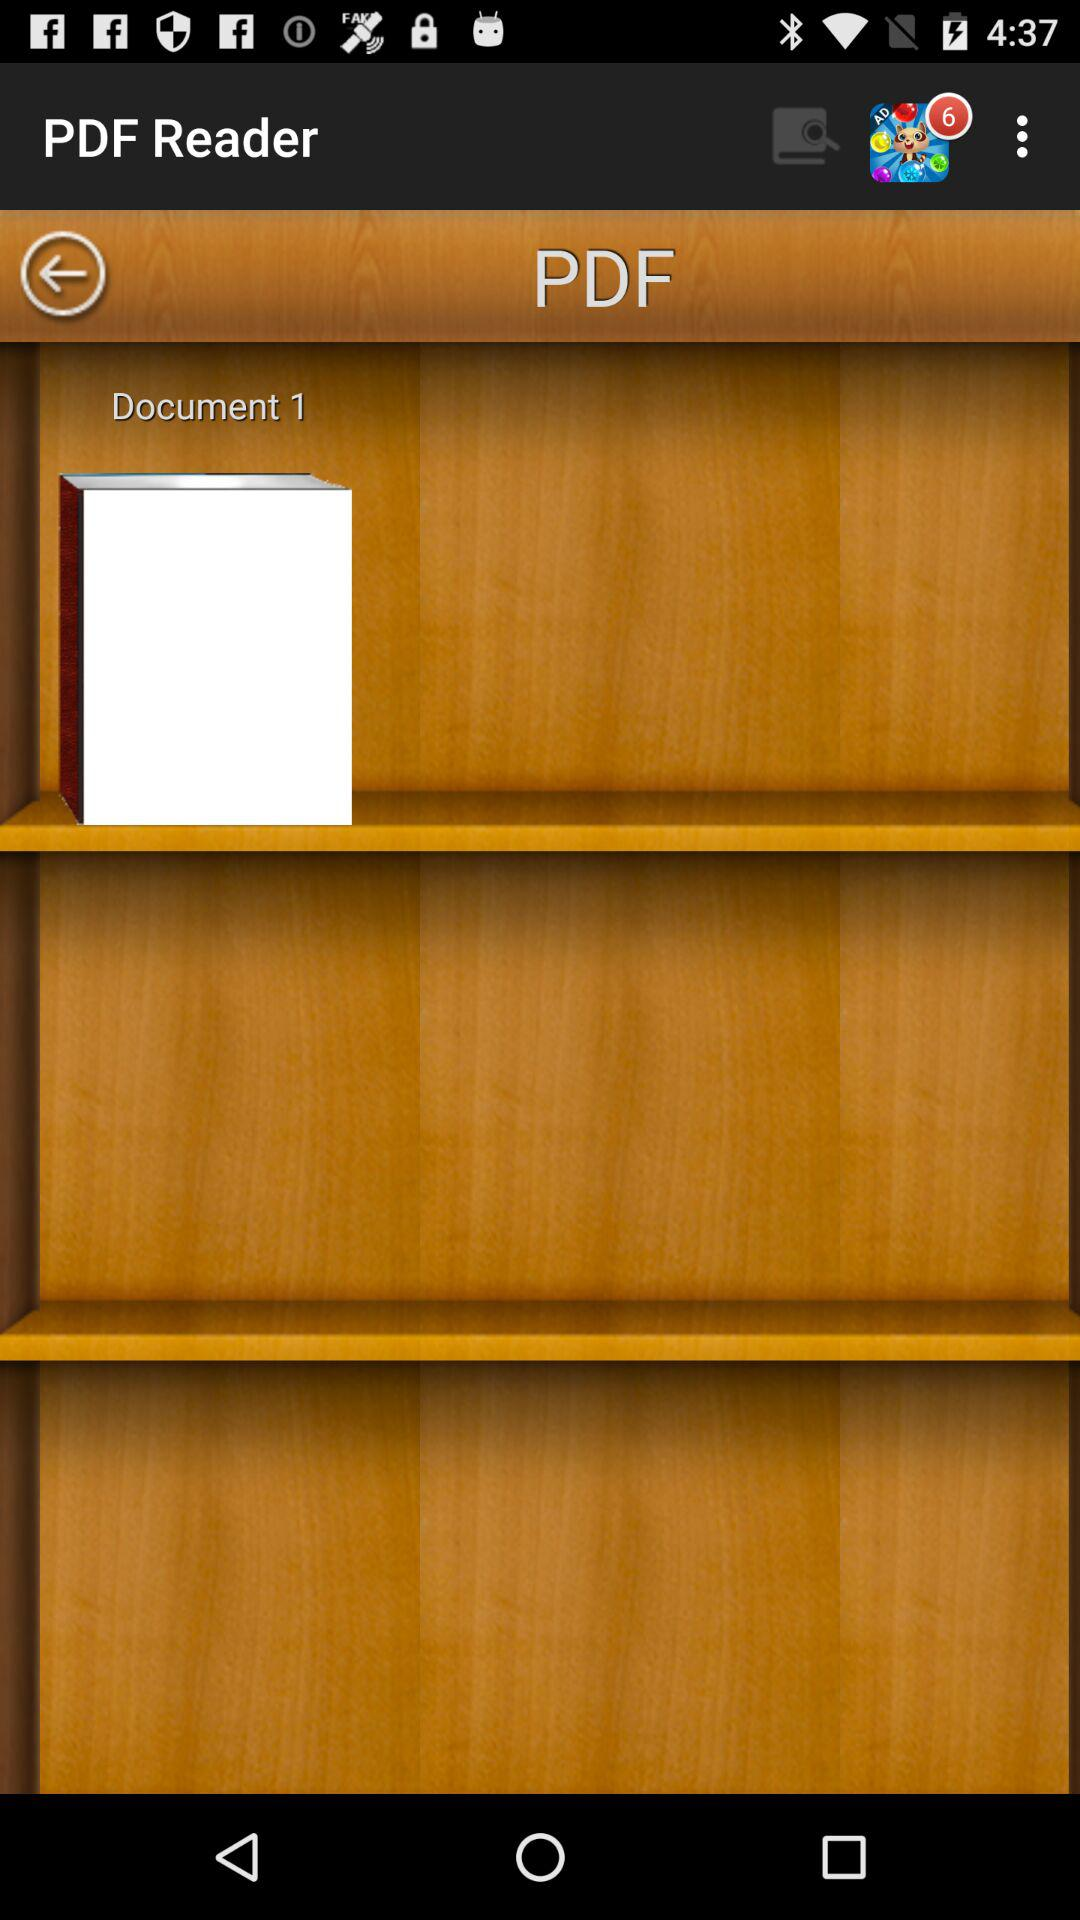What is the application name? The application name is "PDF Reader". 